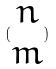Convert formula to latex. <formula><loc_0><loc_0><loc_500><loc_500>( \begin{matrix} n \\ m \end{matrix} )</formula> 